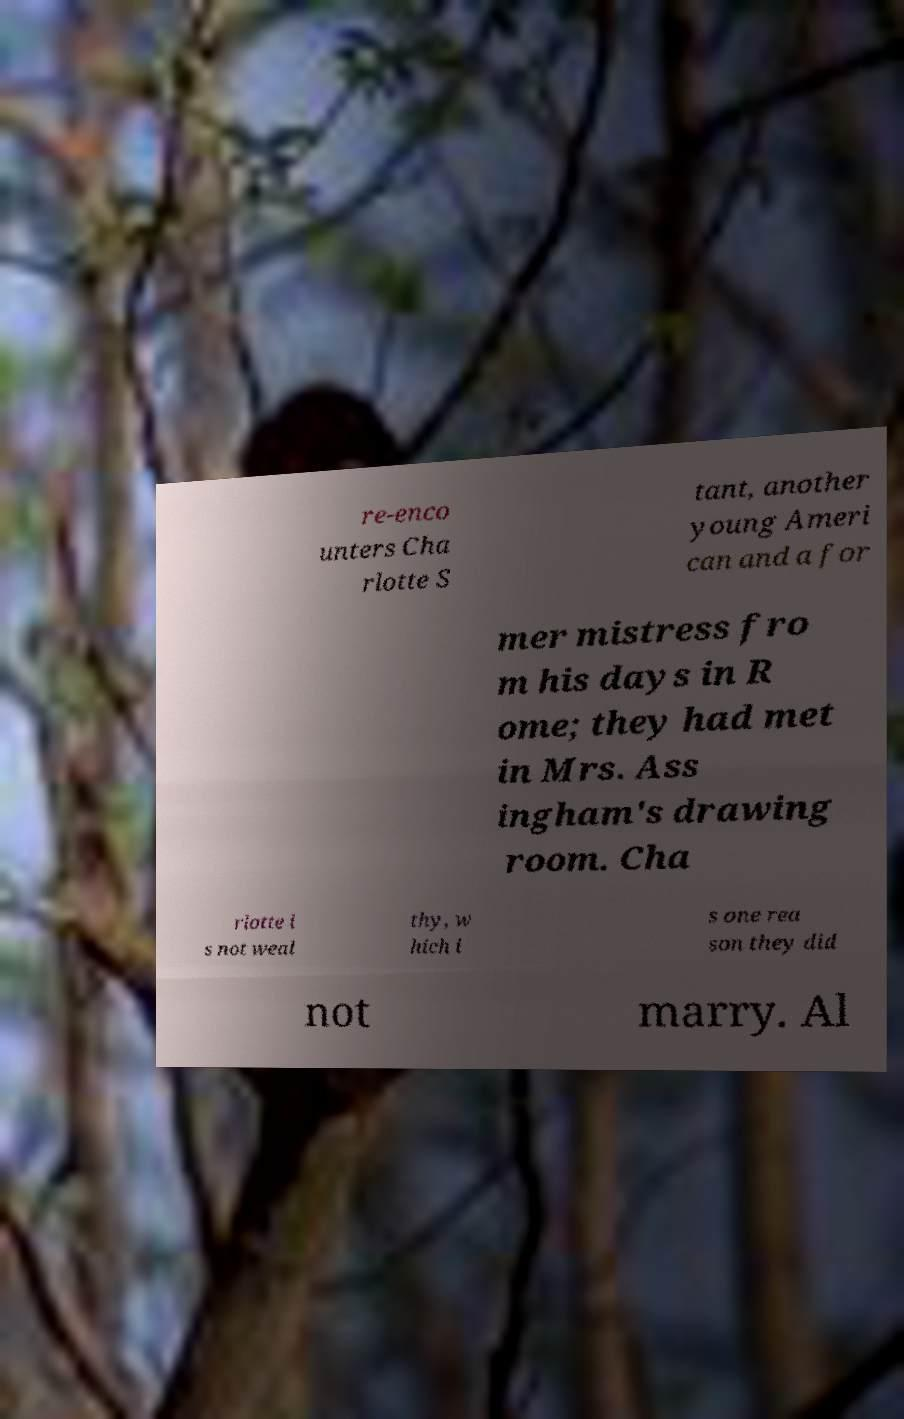Could you assist in decoding the text presented in this image and type it out clearly? re-enco unters Cha rlotte S tant, another young Ameri can and a for mer mistress fro m his days in R ome; they had met in Mrs. Ass ingham's drawing room. Cha rlotte i s not weal thy, w hich i s one rea son they did not marry. Al 